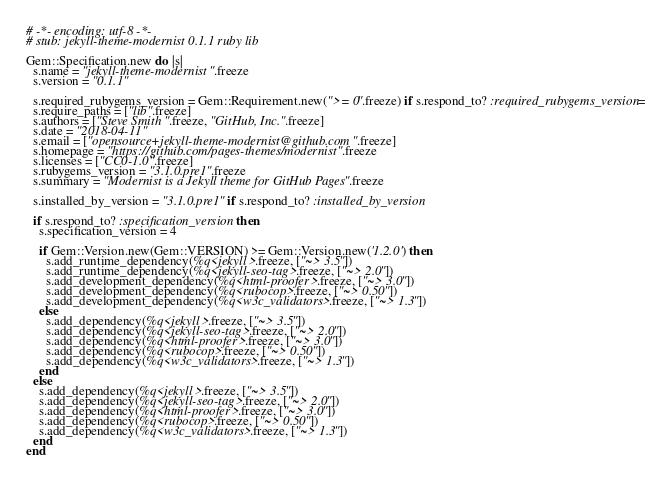<code> <loc_0><loc_0><loc_500><loc_500><_Ruby_># -*- encoding: utf-8 -*-
# stub: jekyll-theme-modernist 0.1.1 ruby lib

Gem::Specification.new do |s|
  s.name = "jekyll-theme-modernist".freeze
  s.version = "0.1.1"

  s.required_rubygems_version = Gem::Requirement.new(">= 0".freeze) if s.respond_to? :required_rubygems_version=
  s.require_paths = ["lib".freeze]
  s.authors = ["Steve Smith".freeze, "GitHub, Inc.".freeze]
  s.date = "2018-04-11"
  s.email = ["opensource+jekyll-theme-modernist@github.com".freeze]
  s.homepage = "https://github.com/pages-themes/modernist".freeze
  s.licenses = ["CC0-1.0".freeze]
  s.rubygems_version = "3.1.0.pre1".freeze
  s.summary = "Modernist is a Jekyll theme for GitHub Pages".freeze

  s.installed_by_version = "3.1.0.pre1" if s.respond_to? :installed_by_version

  if s.respond_to? :specification_version then
    s.specification_version = 4

    if Gem::Version.new(Gem::VERSION) >= Gem::Version.new('1.2.0') then
      s.add_runtime_dependency(%q<jekyll>.freeze, ["~> 3.5"])
      s.add_runtime_dependency(%q<jekyll-seo-tag>.freeze, ["~> 2.0"])
      s.add_development_dependency(%q<html-proofer>.freeze, ["~> 3.0"])
      s.add_development_dependency(%q<rubocop>.freeze, ["~> 0.50"])
      s.add_development_dependency(%q<w3c_validators>.freeze, ["~> 1.3"])
    else
      s.add_dependency(%q<jekyll>.freeze, ["~> 3.5"])
      s.add_dependency(%q<jekyll-seo-tag>.freeze, ["~> 2.0"])
      s.add_dependency(%q<html-proofer>.freeze, ["~> 3.0"])
      s.add_dependency(%q<rubocop>.freeze, ["~> 0.50"])
      s.add_dependency(%q<w3c_validators>.freeze, ["~> 1.3"])
    end
  else
    s.add_dependency(%q<jekyll>.freeze, ["~> 3.5"])
    s.add_dependency(%q<jekyll-seo-tag>.freeze, ["~> 2.0"])
    s.add_dependency(%q<html-proofer>.freeze, ["~> 3.0"])
    s.add_dependency(%q<rubocop>.freeze, ["~> 0.50"])
    s.add_dependency(%q<w3c_validators>.freeze, ["~> 1.3"])
  end
end
</code> 